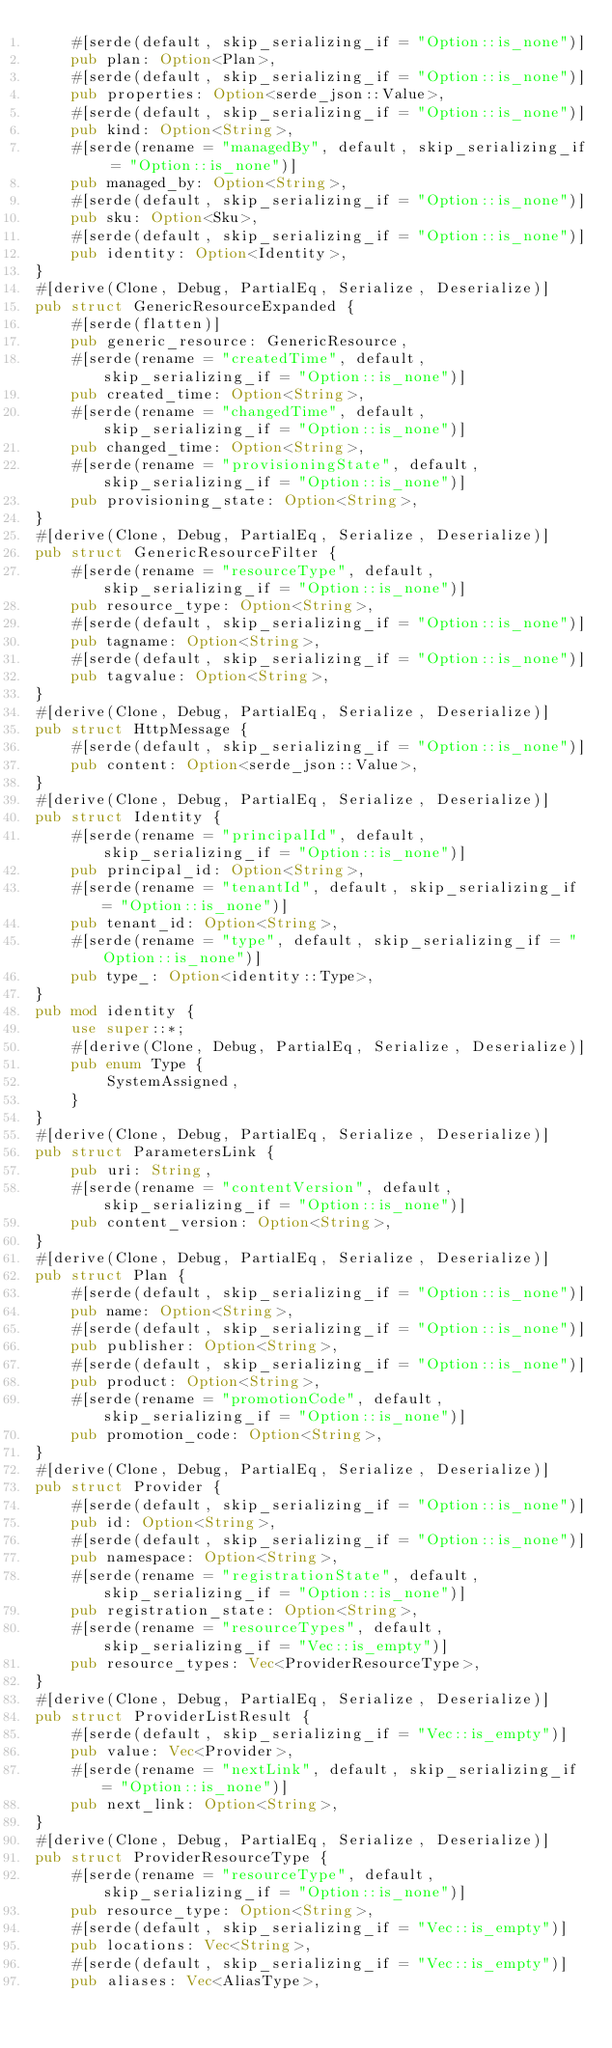Convert code to text. <code><loc_0><loc_0><loc_500><loc_500><_Rust_>    #[serde(default, skip_serializing_if = "Option::is_none")]
    pub plan: Option<Plan>,
    #[serde(default, skip_serializing_if = "Option::is_none")]
    pub properties: Option<serde_json::Value>,
    #[serde(default, skip_serializing_if = "Option::is_none")]
    pub kind: Option<String>,
    #[serde(rename = "managedBy", default, skip_serializing_if = "Option::is_none")]
    pub managed_by: Option<String>,
    #[serde(default, skip_serializing_if = "Option::is_none")]
    pub sku: Option<Sku>,
    #[serde(default, skip_serializing_if = "Option::is_none")]
    pub identity: Option<Identity>,
}
#[derive(Clone, Debug, PartialEq, Serialize, Deserialize)]
pub struct GenericResourceExpanded {
    #[serde(flatten)]
    pub generic_resource: GenericResource,
    #[serde(rename = "createdTime", default, skip_serializing_if = "Option::is_none")]
    pub created_time: Option<String>,
    #[serde(rename = "changedTime", default, skip_serializing_if = "Option::is_none")]
    pub changed_time: Option<String>,
    #[serde(rename = "provisioningState", default, skip_serializing_if = "Option::is_none")]
    pub provisioning_state: Option<String>,
}
#[derive(Clone, Debug, PartialEq, Serialize, Deserialize)]
pub struct GenericResourceFilter {
    #[serde(rename = "resourceType", default, skip_serializing_if = "Option::is_none")]
    pub resource_type: Option<String>,
    #[serde(default, skip_serializing_if = "Option::is_none")]
    pub tagname: Option<String>,
    #[serde(default, skip_serializing_if = "Option::is_none")]
    pub tagvalue: Option<String>,
}
#[derive(Clone, Debug, PartialEq, Serialize, Deserialize)]
pub struct HttpMessage {
    #[serde(default, skip_serializing_if = "Option::is_none")]
    pub content: Option<serde_json::Value>,
}
#[derive(Clone, Debug, PartialEq, Serialize, Deserialize)]
pub struct Identity {
    #[serde(rename = "principalId", default, skip_serializing_if = "Option::is_none")]
    pub principal_id: Option<String>,
    #[serde(rename = "tenantId", default, skip_serializing_if = "Option::is_none")]
    pub tenant_id: Option<String>,
    #[serde(rename = "type", default, skip_serializing_if = "Option::is_none")]
    pub type_: Option<identity::Type>,
}
pub mod identity {
    use super::*;
    #[derive(Clone, Debug, PartialEq, Serialize, Deserialize)]
    pub enum Type {
        SystemAssigned,
    }
}
#[derive(Clone, Debug, PartialEq, Serialize, Deserialize)]
pub struct ParametersLink {
    pub uri: String,
    #[serde(rename = "contentVersion", default, skip_serializing_if = "Option::is_none")]
    pub content_version: Option<String>,
}
#[derive(Clone, Debug, PartialEq, Serialize, Deserialize)]
pub struct Plan {
    #[serde(default, skip_serializing_if = "Option::is_none")]
    pub name: Option<String>,
    #[serde(default, skip_serializing_if = "Option::is_none")]
    pub publisher: Option<String>,
    #[serde(default, skip_serializing_if = "Option::is_none")]
    pub product: Option<String>,
    #[serde(rename = "promotionCode", default, skip_serializing_if = "Option::is_none")]
    pub promotion_code: Option<String>,
}
#[derive(Clone, Debug, PartialEq, Serialize, Deserialize)]
pub struct Provider {
    #[serde(default, skip_serializing_if = "Option::is_none")]
    pub id: Option<String>,
    #[serde(default, skip_serializing_if = "Option::is_none")]
    pub namespace: Option<String>,
    #[serde(rename = "registrationState", default, skip_serializing_if = "Option::is_none")]
    pub registration_state: Option<String>,
    #[serde(rename = "resourceTypes", default, skip_serializing_if = "Vec::is_empty")]
    pub resource_types: Vec<ProviderResourceType>,
}
#[derive(Clone, Debug, PartialEq, Serialize, Deserialize)]
pub struct ProviderListResult {
    #[serde(default, skip_serializing_if = "Vec::is_empty")]
    pub value: Vec<Provider>,
    #[serde(rename = "nextLink", default, skip_serializing_if = "Option::is_none")]
    pub next_link: Option<String>,
}
#[derive(Clone, Debug, PartialEq, Serialize, Deserialize)]
pub struct ProviderResourceType {
    #[serde(rename = "resourceType", default, skip_serializing_if = "Option::is_none")]
    pub resource_type: Option<String>,
    #[serde(default, skip_serializing_if = "Vec::is_empty")]
    pub locations: Vec<String>,
    #[serde(default, skip_serializing_if = "Vec::is_empty")]
    pub aliases: Vec<AliasType>,</code> 